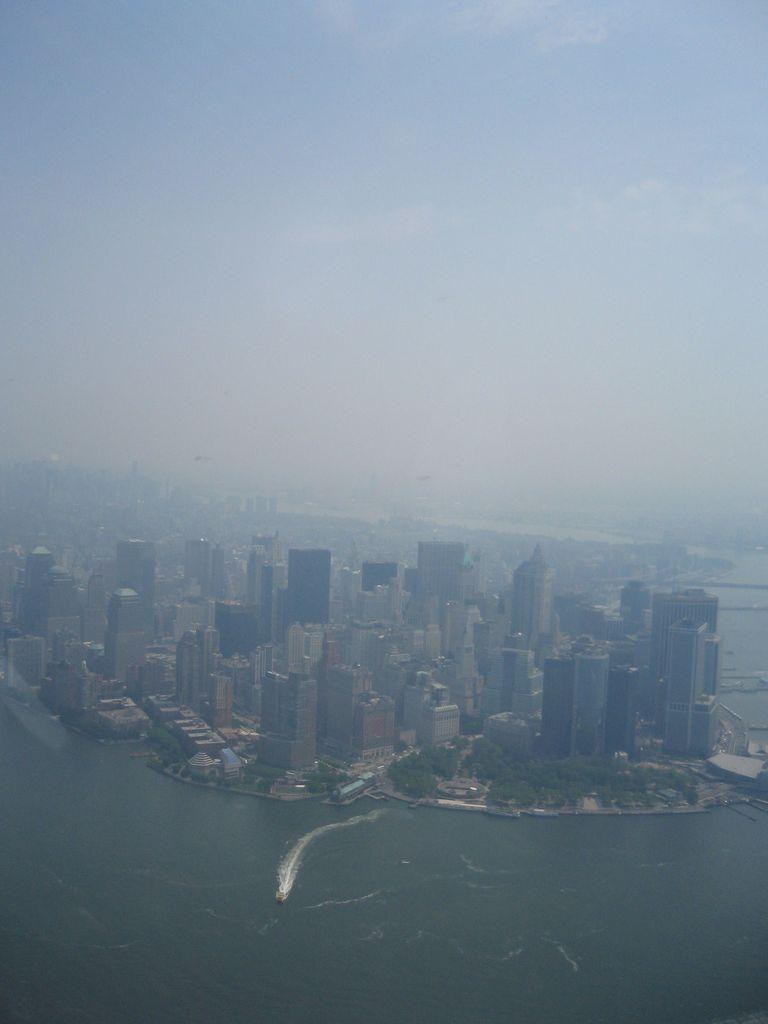What can be observed about the background of the image? The background portion of the picture is blurred. What part of the natural environment is visible in the image? The sky is visible in the image. What type of structures can be seen in the image? There are buildings in the image. What type of vegetation is present in the image? Trees are present in the image. What body of water can be seen in the image? There is water visible in the image. How many ducks are swimming in the water in the image? There are no ducks present in the image; it features a blurred background, sky, buildings, trees, and water. What type of yarn is the visitor holding in the image? There is no visitor present in the image, as it primarily focuses on the background, sky, buildings, trees, and water. 